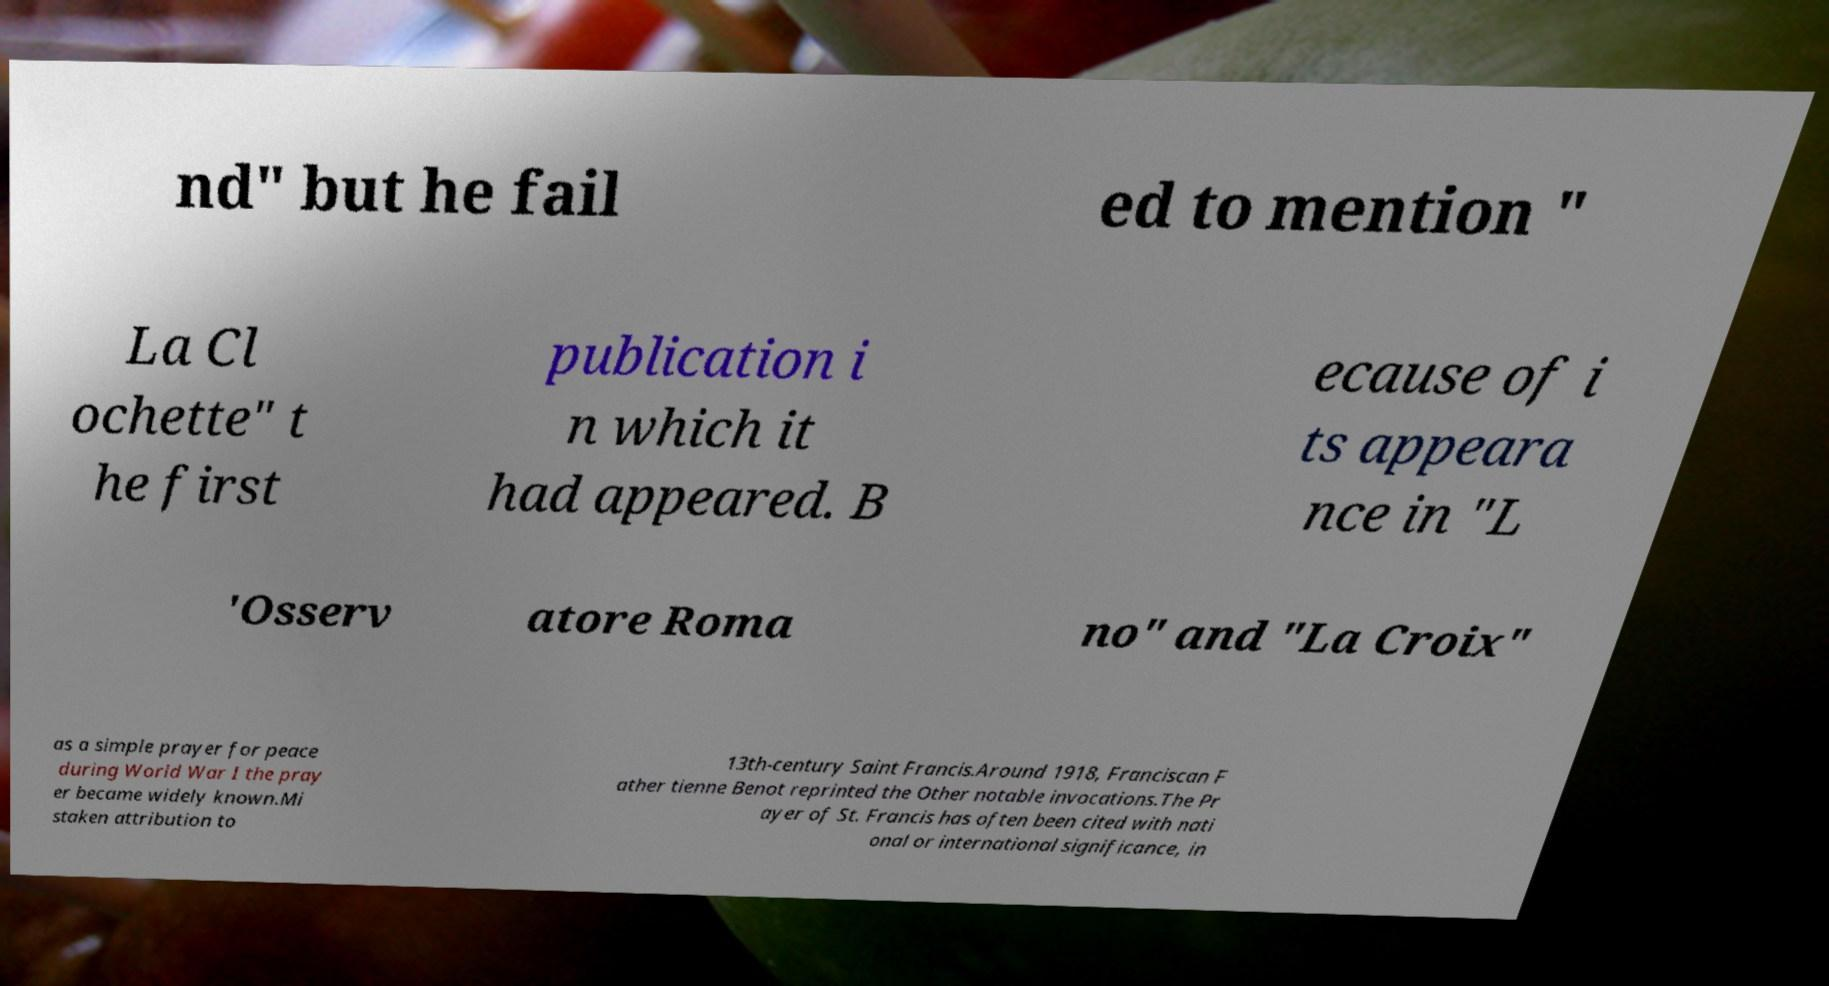Can you read and provide the text displayed in the image?This photo seems to have some interesting text. Can you extract and type it out for me? nd" but he fail ed to mention " La Cl ochette" t he first publication i n which it had appeared. B ecause of i ts appeara nce in "L 'Osserv atore Roma no" and "La Croix" as a simple prayer for peace during World War I the pray er became widely known.Mi staken attribution to 13th-century Saint Francis.Around 1918, Franciscan F ather tienne Benot reprinted the Other notable invocations.The Pr ayer of St. Francis has often been cited with nati onal or international significance, in 